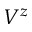Convert formula to latex. <formula><loc_0><loc_0><loc_500><loc_500>V ^ { z }</formula> 